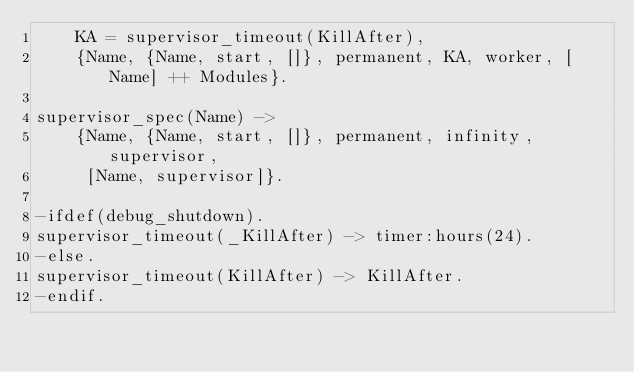<code> <loc_0><loc_0><loc_500><loc_500><_Erlang_>    KA = supervisor_timeout(KillAfter),
    {Name, {Name, start, []}, permanent, KA, worker, [Name] ++ Modules}.

supervisor_spec(Name) ->
    {Name, {Name, start, []}, permanent, infinity, supervisor,
     [Name, supervisor]}.
    
-ifdef(debug_shutdown).
supervisor_timeout(_KillAfter) -> timer:hours(24).
-else.
supervisor_timeout(KillAfter) -> KillAfter.
-endif.    

    
</code> 